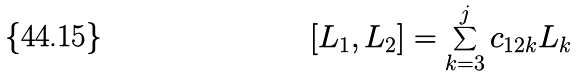<formula> <loc_0><loc_0><loc_500><loc_500>[ L _ { 1 } , L _ { 2 } ] = \sum _ { k = 3 } ^ { j } c _ { 1 2 k } L _ { k }</formula> 